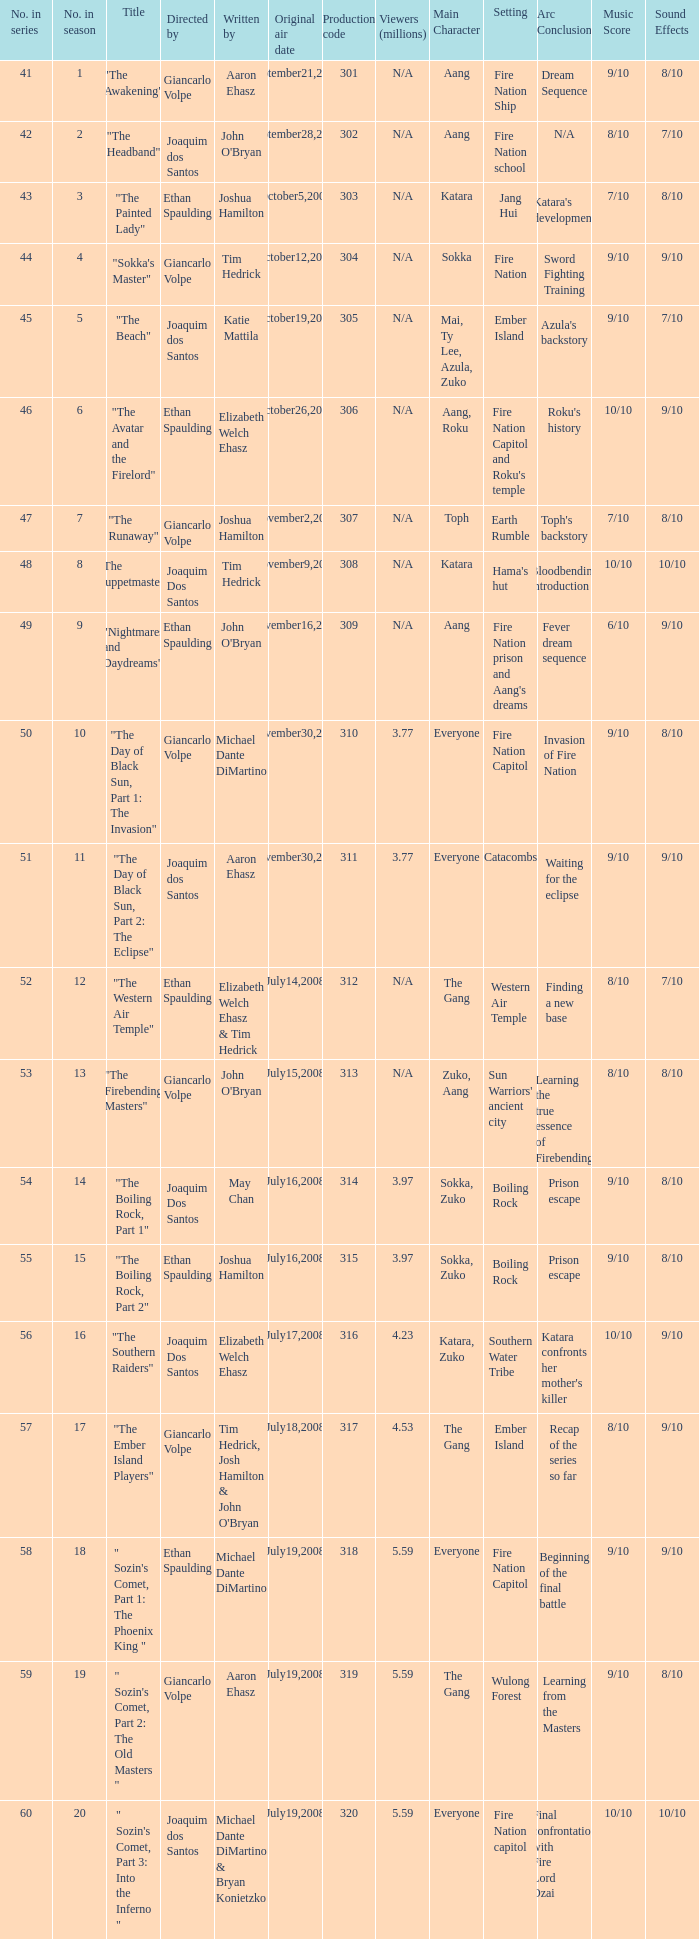What season has an episode written by john o'bryan and directed by ethan spaulding? 9.0. 